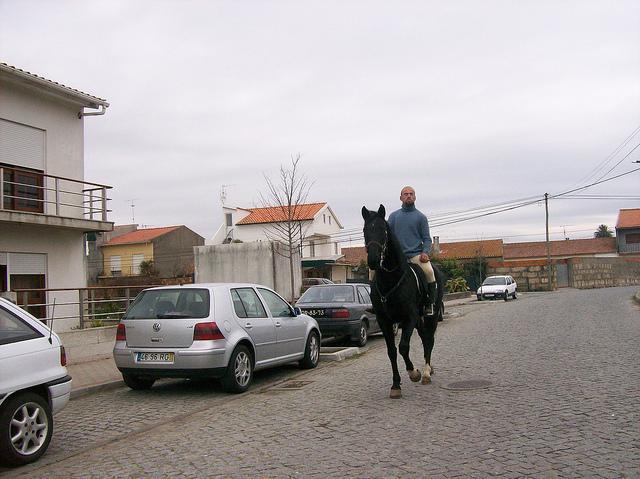How many horses are there?
Give a very brief answer. 1. How many dump trucks are in this photo?
Give a very brief answer. 0. How many cars are there?
Give a very brief answer. 4. How many cars can you see?
Give a very brief answer. 3. How many orange stripes are on the sail?
Give a very brief answer. 0. 